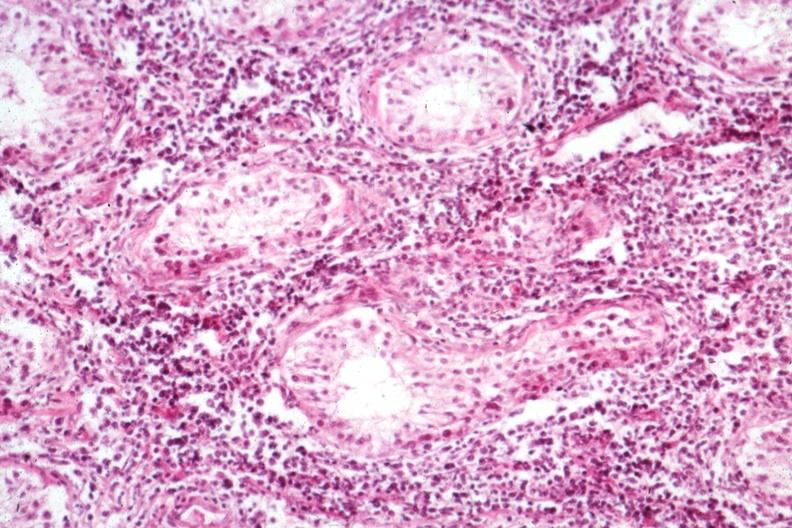does this image show interstitial infiltrate well shown not the best morphology?
Answer the question using a single word or phrase. Yes 